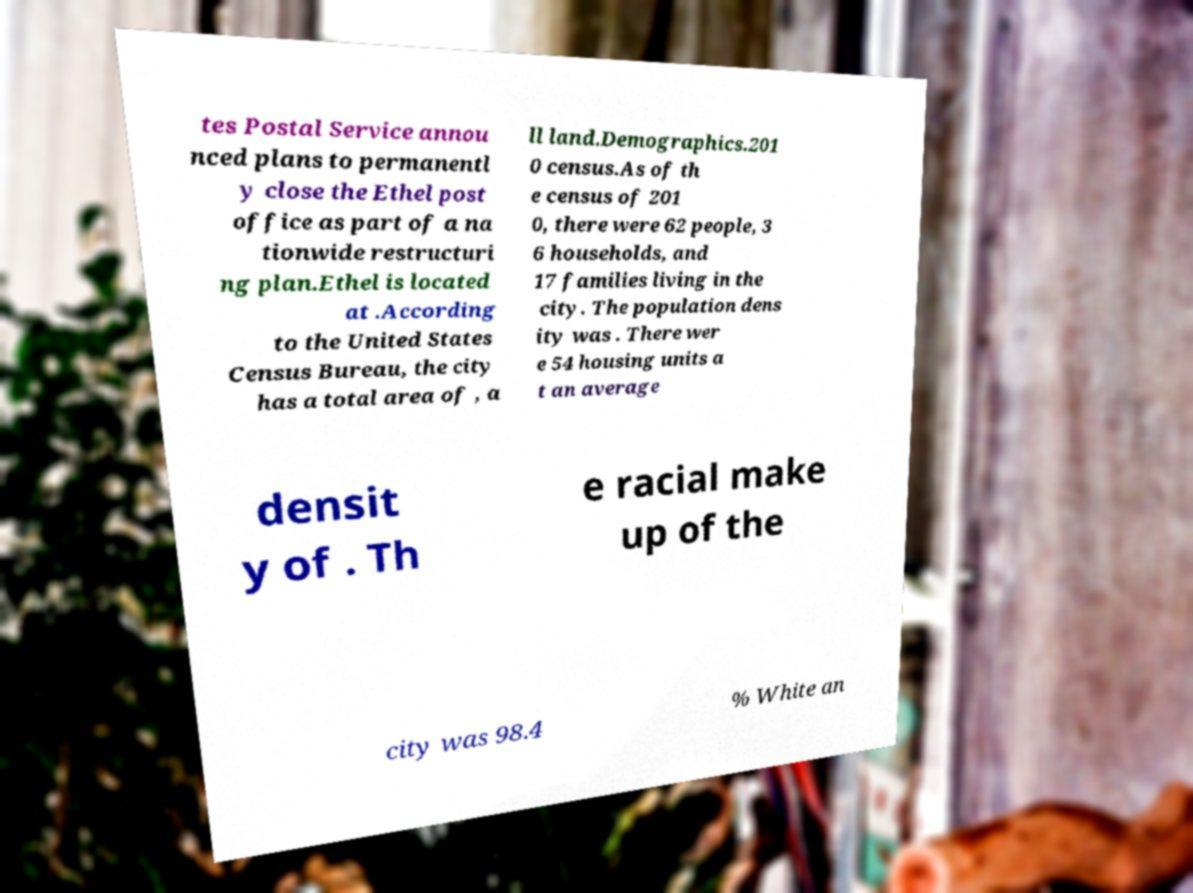What messages or text are displayed in this image? I need them in a readable, typed format. tes Postal Service annou nced plans to permanentl y close the Ethel post office as part of a na tionwide restructuri ng plan.Ethel is located at .According to the United States Census Bureau, the city has a total area of , a ll land.Demographics.201 0 census.As of th e census of 201 0, there were 62 people, 3 6 households, and 17 families living in the city. The population dens ity was . There wer e 54 housing units a t an average densit y of . Th e racial make up of the city was 98.4 % White an 